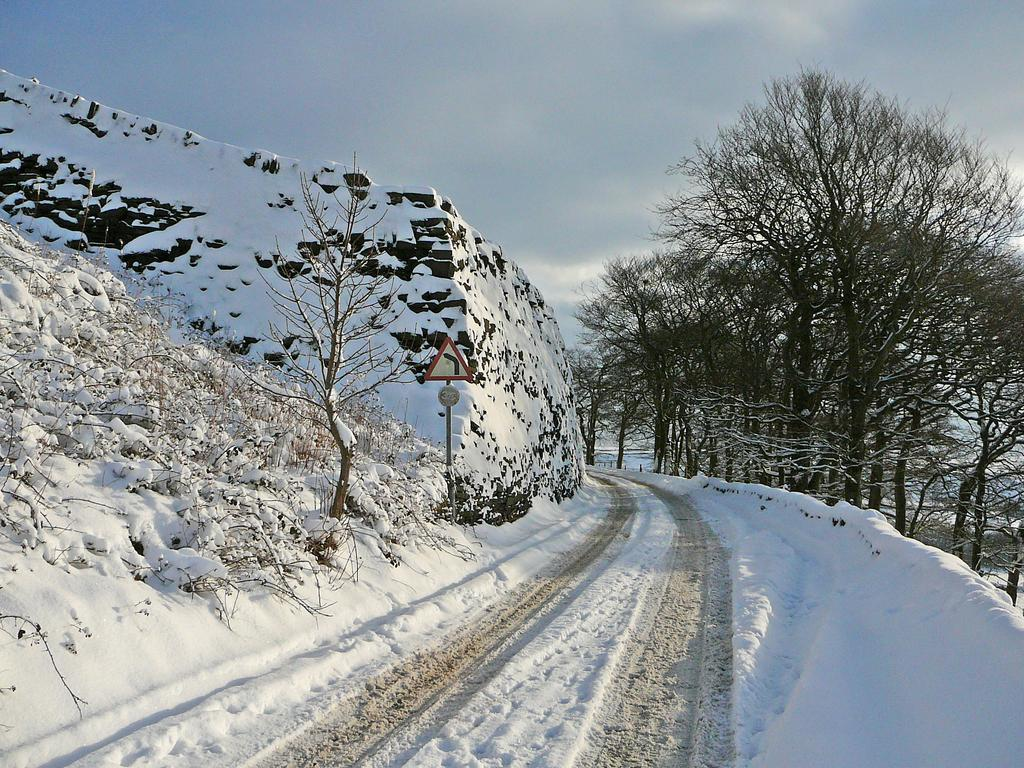What type of vegetation can be seen in the image? There are trees in the image. What geographical feature is located on the left side of the image? There is a hill on the left side of the image. What is covering the hill in the image? There is snow on the hill. What is visible at the top of the image? Clouds are visible at the top of the image. What is present at the bottom of the image? Snow is present at the bottom of the image. How many slaves are visible in the image? There are no slaves present in the image. What type of stove can be seen in the image? There is no stove present in the image. 